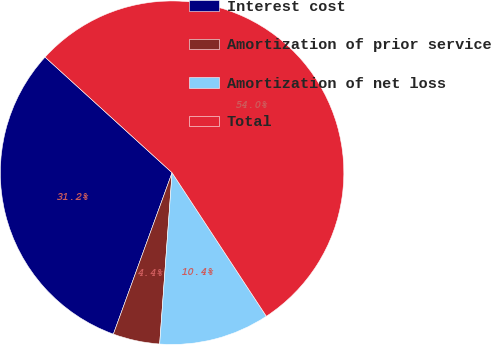Convert chart. <chart><loc_0><loc_0><loc_500><loc_500><pie_chart><fcel>Interest cost<fcel>Amortization of prior service<fcel>Amortization of net loss<fcel>Total<nl><fcel>31.2%<fcel>4.4%<fcel>10.4%<fcel>54.0%<nl></chart> 